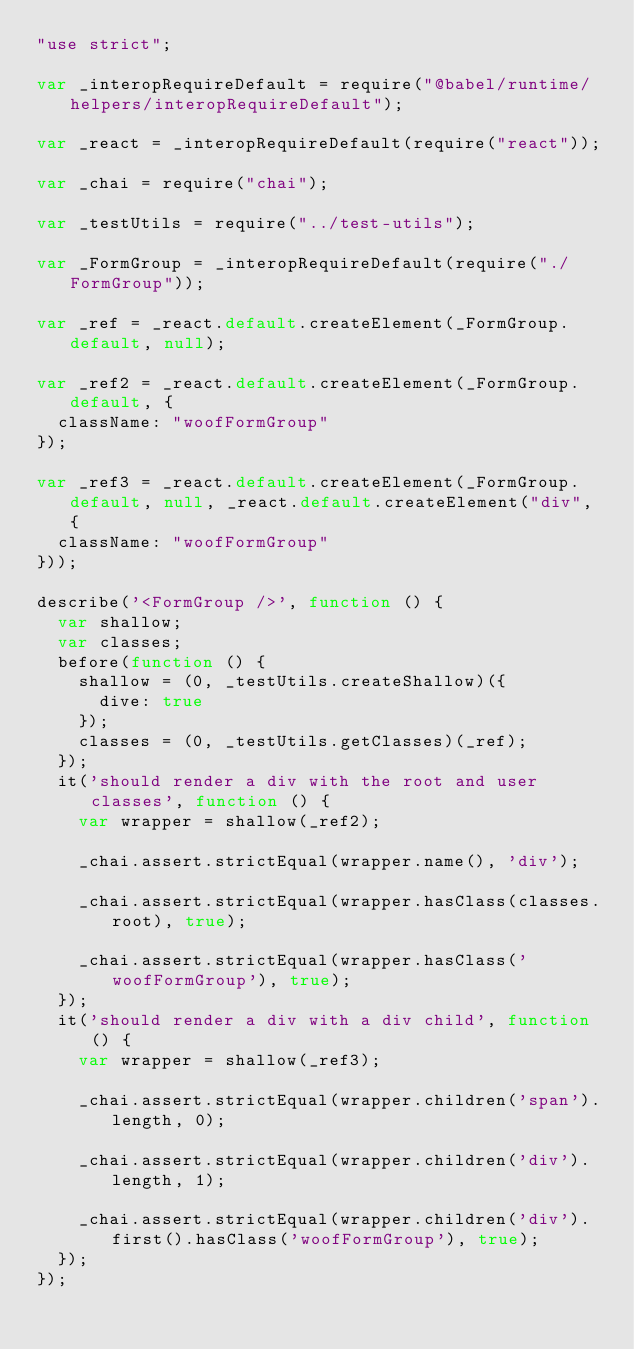Convert code to text. <code><loc_0><loc_0><loc_500><loc_500><_JavaScript_>"use strict";

var _interopRequireDefault = require("@babel/runtime/helpers/interopRequireDefault");

var _react = _interopRequireDefault(require("react"));

var _chai = require("chai");

var _testUtils = require("../test-utils");

var _FormGroup = _interopRequireDefault(require("./FormGroup"));

var _ref = _react.default.createElement(_FormGroup.default, null);

var _ref2 = _react.default.createElement(_FormGroup.default, {
  className: "woofFormGroup"
});

var _ref3 = _react.default.createElement(_FormGroup.default, null, _react.default.createElement("div", {
  className: "woofFormGroup"
}));

describe('<FormGroup />', function () {
  var shallow;
  var classes;
  before(function () {
    shallow = (0, _testUtils.createShallow)({
      dive: true
    });
    classes = (0, _testUtils.getClasses)(_ref);
  });
  it('should render a div with the root and user classes', function () {
    var wrapper = shallow(_ref2);

    _chai.assert.strictEqual(wrapper.name(), 'div');

    _chai.assert.strictEqual(wrapper.hasClass(classes.root), true);

    _chai.assert.strictEqual(wrapper.hasClass('woofFormGroup'), true);
  });
  it('should render a div with a div child', function () {
    var wrapper = shallow(_ref3);

    _chai.assert.strictEqual(wrapper.children('span').length, 0);

    _chai.assert.strictEqual(wrapper.children('div').length, 1);

    _chai.assert.strictEqual(wrapper.children('div').first().hasClass('woofFormGroup'), true);
  });
});</code> 